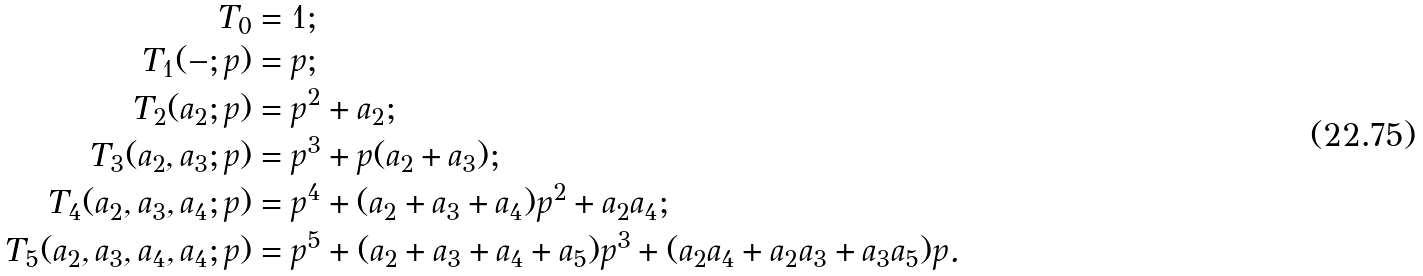Convert formula to latex. <formula><loc_0><loc_0><loc_500><loc_500>T _ { 0 } & = 1 ; \\ T _ { 1 } ( - ; p ) & = p ; \\ T _ { 2 } ( a _ { 2 } ; p ) & = p ^ { 2 } + a _ { 2 } ; \\ T _ { 3 } ( a _ { 2 } , a _ { 3 } ; p ) & = p ^ { 3 } + p ( a _ { 2 } + a _ { 3 } ) ; \\ T _ { 4 } ( a _ { 2 } , a _ { 3 } , a _ { 4 } ; p ) & = p ^ { 4 } + ( a _ { 2 } + a _ { 3 } + a _ { 4 } ) p ^ { 2 } + a _ { 2 } a _ { 4 } ; \\ T _ { 5 } ( a _ { 2 } , a _ { 3 } , a _ { 4 } , a _ { 4 } ; p ) & = p ^ { 5 } + ( a _ { 2 } + a _ { 3 } + a _ { 4 } + a _ { 5 } ) p ^ { 3 } + ( a _ { 2 } a _ { 4 } + a _ { 2 } a _ { 3 } + a _ { 3 } a _ { 5 } ) p .</formula> 